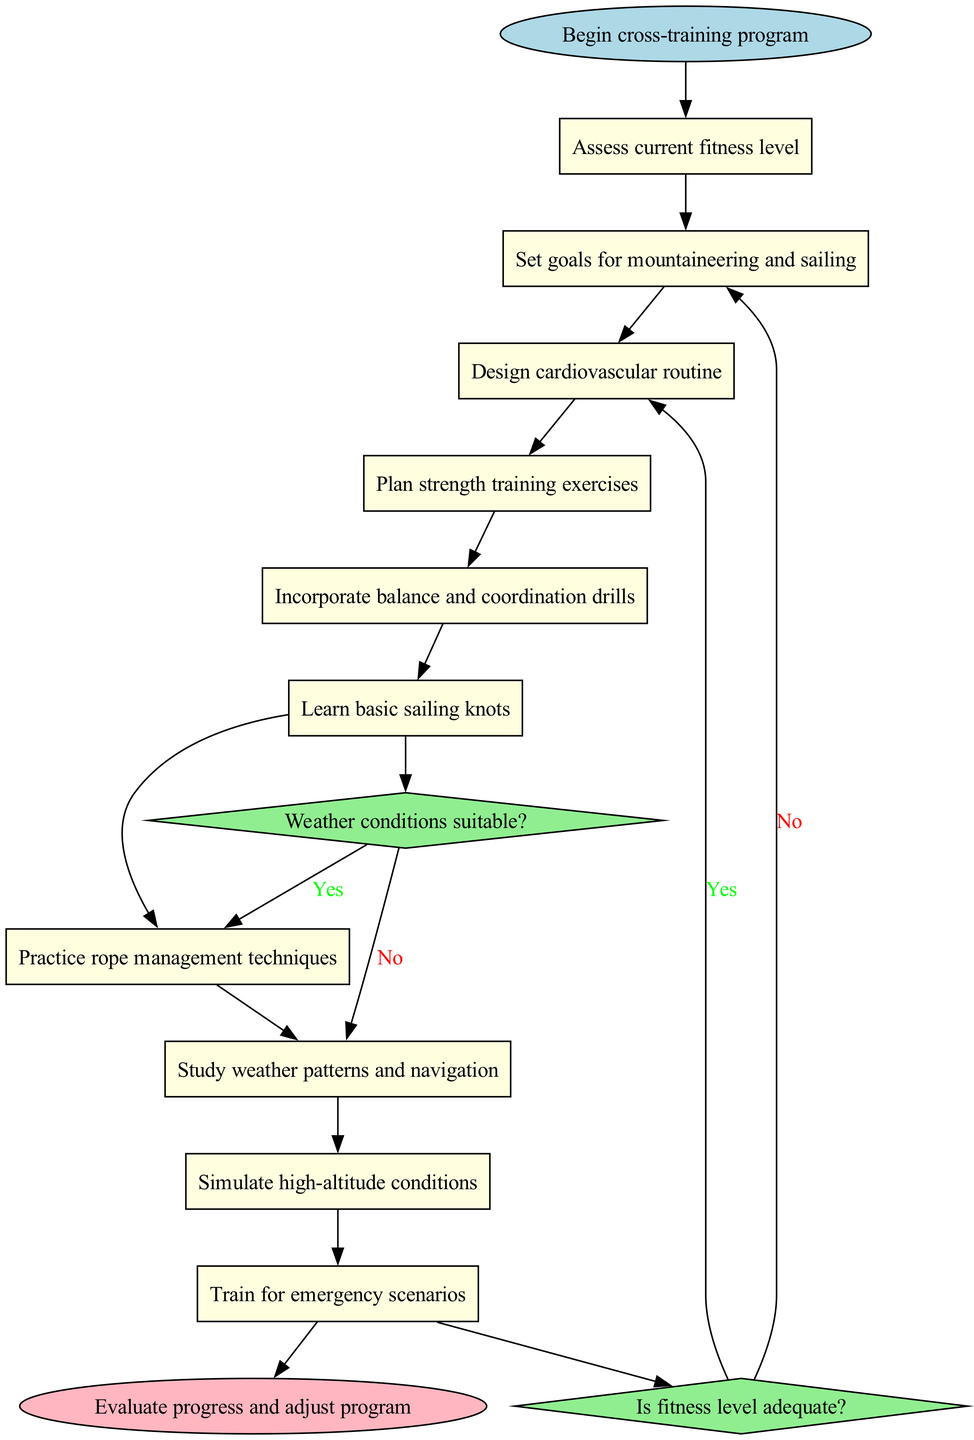What is the starting node of the cross-training program? The starting node is indicated at the beginning of the diagram, labeled "Begin cross-training program."
Answer: Begin cross-training program How many activities are included in the cross-training program? To find the number of activities, I count each of the items listed under the "activities" section, which totals to 10.
Answer: 10 What is the last activity before making a decision? The last activity listed before any decision nodes in the flow is "Train for emergency scenarios."
Answer: Train for emergency scenarios Which activity follows "Learn basic sailing knots"? By following the flow from the node "Learn basic sailing knots," the next activity is "Practice rope management techniques."
Answer: Practice rope management techniques What happens if the fitness level is not adequate? The diagram states that if the fitness level is not adequate, the next step is to "Adjust training intensity."
Answer: Adjust training intensity How many decision nodes are present in the diagram? I count the number of decision nodes labeled "Is fitness level adequate?" and "Weather conditions suitable?" which makes a total of 2.
Answer: 2 What is the end node of the cross-training program? The end node is clearly labeled at the bottom of the diagram as "Evaluate progress and adjust program."
Answer: Evaluate progress and adjust program What are the consequences if weather conditions are not suitable? If weather conditions are not suitable, the flow indicates that the next step is to "Focus on indoor exercises."
Answer: Focus on indoor exercises Which decision is associated with assessing fitness levels? The decision node related to assessing fitness levels is "Is fitness level adequate?"
Answer: Is fitness level adequate What activity is linked to the decision on weather conditions? The decisions based on weather conditions are connected to "Conduct outdoor training" if yes and "Focus on indoor exercises" if no, with the first decision node being the link.
Answer: Conduct outdoor training 